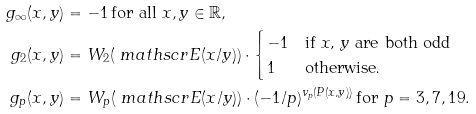<formula> <loc_0><loc_0><loc_500><loc_500>g _ { \infty } ( x , y ) & = - 1 \, \text {for all $x,y\in \mathbb{R}$} , \\ g _ { 2 } ( x , y ) & = W _ { 2 } ( \ m a t h s c r { E } ( x / y ) ) \cdot \begin{cases} - 1 & \text {if $x$, $y$ are both odd} \\ 1 & \text {otherwise.} \end{cases} \\ g _ { p } ( x , y ) & = W _ { p } ( \ m a t h s c r { E } ( x / y ) ) \cdot ( - 1 / p ) ^ { v _ { p } ( P ( x , y ) ) } \, \text {for $p=3,7,19$} .</formula> 